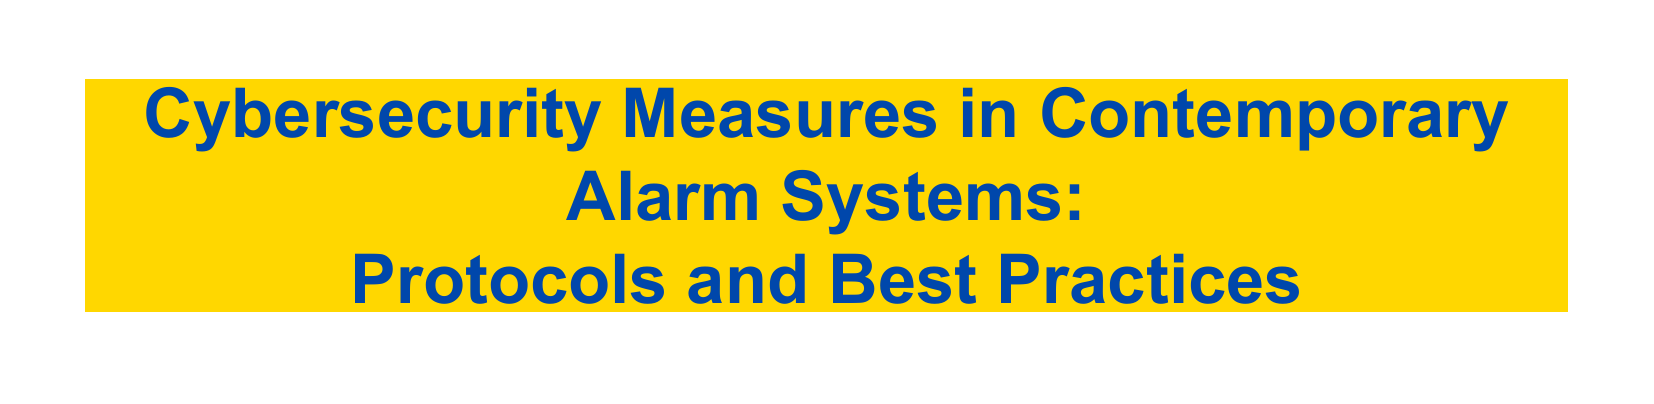What is the first section of the document? The first section listed in the Table of Contents is "Introduction to Cybersecurity in Alarm Systems."
Answer: Introduction to Cybersecurity in Alarm Systems How many subsections are in "Common Cyber Threats Facing Alarm Systems"? The section "Common Cyber Threats Facing Alarm Systems" contains two subsections.
Answer: 2 Which protocol is mentioned as part of cybersecurity measures? The document lists "Encryption Techniques and Standards" under the section for cybersecurity protocols.
Answer: Encryption Techniques and Standards What is one of the emerging technologies in cybersecurity for alarm systems? "Artificial Intelligence (AI) and Machine Learning (ML) in Cyber Defense" is mentioned as an emerging technology.
Answer: Artificial Intelligence (AI) and Machine Learning (ML) Which compliance regulation is specified in the legal framework? The document specifies compliance with GDPR as part of the legal and regulatory frameworks.
Answer: GDPR What type of cybersecurity measure is regularly performed according to best practices? The document highlights "Regular Software/Hardware Updates" as a proactive measure within best practices.
Answer: Regular Software/Hardware Updates What is the last section of the Table of Contents? The last section is "Future Directions."
Answer: Future Directions How many best practices for securing alarm systems are listed? There are three best practices listed in that section of the document.
Answer: 3 